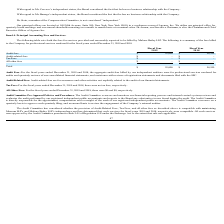According to Protagenic Therapeutics's financial document, What are the tax fees for the fiscal year ended December 2018? There were no tax fees. The document states: "he fiscal years ended December 31, 2019 and 2018, there were no tax fees, respectively. All Other Fees: For the fiscal years ended December 31, 2019 a..." Also, What are the tax fees for the fiscal year ended December 2019? There were no tax fees. The document states: "he fiscal years ended December 31, 2019 and 2018, there were no tax fees, respectively. All Other Fees: For the fiscal years ended December 31, 2019 a..." Also, What does audit-related fees refer to? Assurance and other activities not explicitly related to the audit of our financial statements. The document states: "C. Audit-Related Fees: Audit-related fees are for assurance and other activities not explicitly related to the audit of our financial statements. Tax ..." Also, can you calculate: What is the percentage change in audit fees between 2018 and 2019? To answer this question, I need to perform calculations using the financial data. The calculation is: (55,000 - 54,550)/54,550 , which equals 0.82 (percentage). This is based on the information: "Audit fees $ 55,000 $ 54,550 Audit fees $ 55,000 $ 54,550..." The key data points involved are: 54,550, 55,000. Also, can you calculate: What is the change in audit fees between 2018 and 2019? Based on the calculation: 55,000 - 54,550 , the result is 450. This is based on the information: "Audit fees $ 55,000 $ 54,550 Audit fees $ 55,000 $ 54,550..." The key data points involved are: 54,550, 55,000. Additionally, Which year has the higher audit fees? According to the financial document, 2019. The relevant text states: "rendered for the fiscal years ended December 31, 2019 and 2018...." 